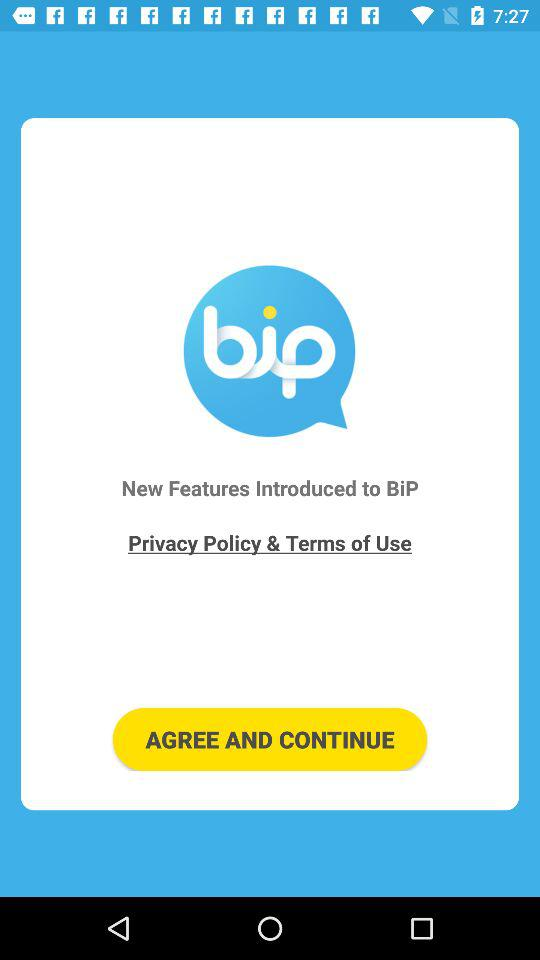What is the name of the application? The name of the application is "BiP - Messenger, Video Call". 